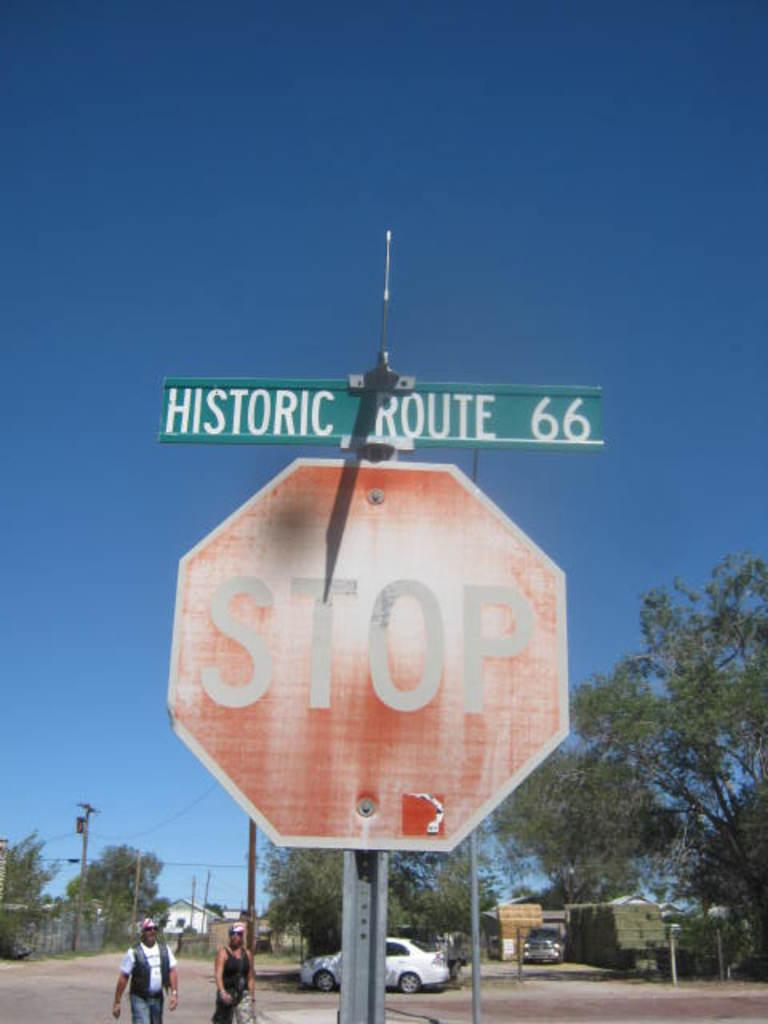Provide a one-sentence caption for the provided image. A stop sign with Historic Route 66 above it. 